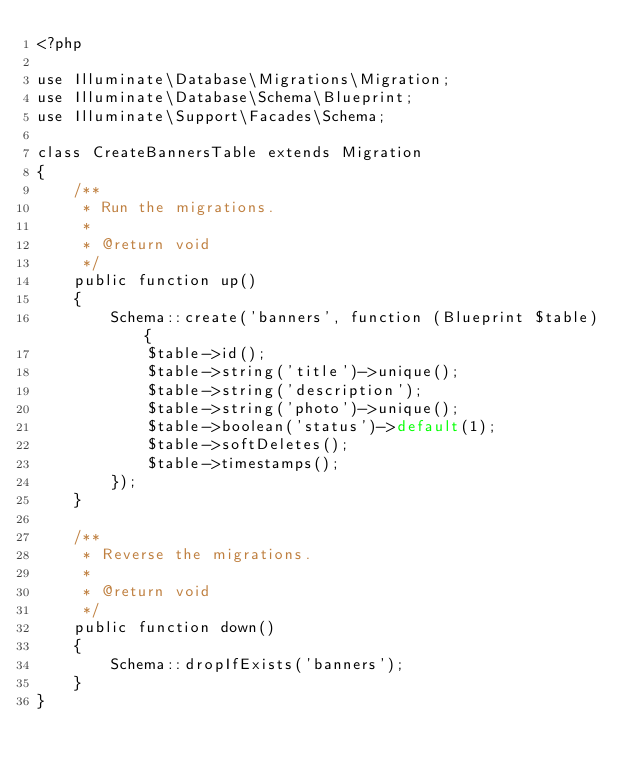<code> <loc_0><loc_0><loc_500><loc_500><_PHP_><?php

use Illuminate\Database\Migrations\Migration;
use Illuminate\Database\Schema\Blueprint;
use Illuminate\Support\Facades\Schema;

class CreateBannersTable extends Migration
{
    /**
     * Run the migrations.
     *
     * @return void
     */
    public function up()
    {
        Schema::create('banners', function (Blueprint $table) {
            $table->id();
            $table->string('title')->unique();
            $table->string('description');
            $table->string('photo')->unique();
            $table->boolean('status')->default(1);
            $table->softDeletes();
            $table->timestamps();
        });
    }

    /**
     * Reverse the migrations.
     *
     * @return void
     */
    public function down()
    {
        Schema::dropIfExists('banners');
    }
}
</code> 